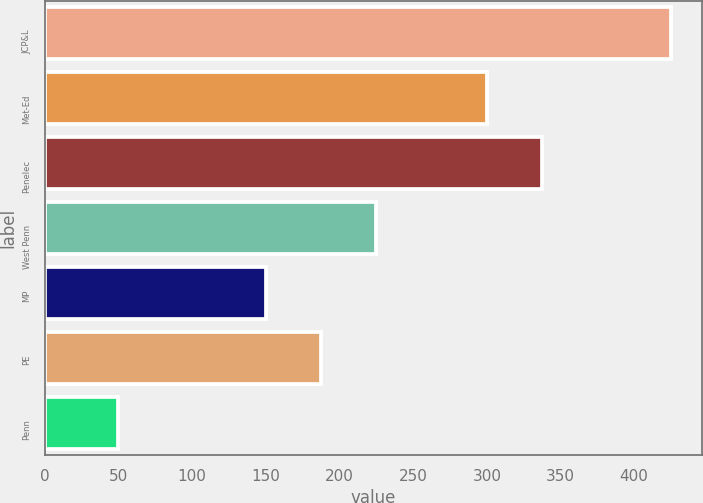Convert chart to OTSL. <chart><loc_0><loc_0><loc_500><loc_500><bar_chart><fcel>JCP&L<fcel>Met-Ed<fcel>Penelec<fcel>West Penn<fcel>MP<fcel>PE<fcel>Penn<nl><fcel>425<fcel>300<fcel>337.5<fcel>225<fcel>150<fcel>187.5<fcel>50<nl></chart> 